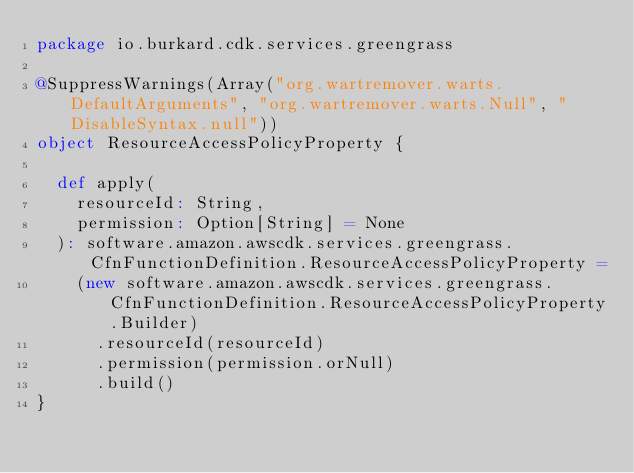Convert code to text. <code><loc_0><loc_0><loc_500><loc_500><_Scala_>package io.burkard.cdk.services.greengrass

@SuppressWarnings(Array("org.wartremover.warts.DefaultArguments", "org.wartremover.warts.Null", "DisableSyntax.null"))
object ResourceAccessPolicyProperty {

  def apply(
    resourceId: String,
    permission: Option[String] = None
  ): software.amazon.awscdk.services.greengrass.CfnFunctionDefinition.ResourceAccessPolicyProperty =
    (new software.amazon.awscdk.services.greengrass.CfnFunctionDefinition.ResourceAccessPolicyProperty.Builder)
      .resourceId(resourceId)
      .permission(permission.orNull)
      .build()
}
</code> 